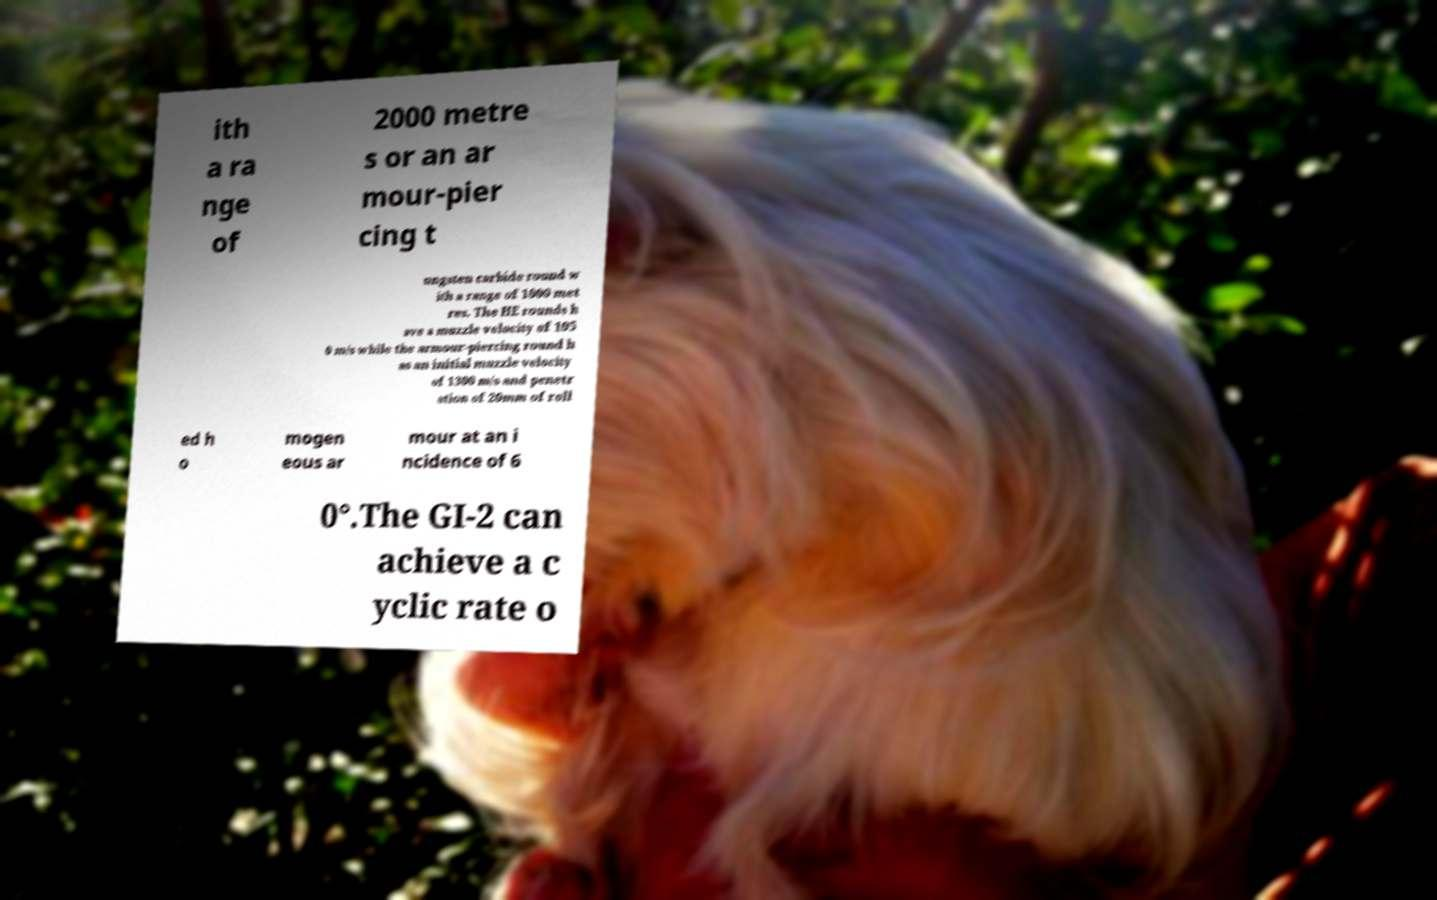I need the written content from this picture converted into text. Can you do that? ith a ra nge of 2000 metre s or an ar mour-pier cing t ungsten carbide round w ith a range of 1000 met res. The HE rounds h ave a muzzle velocity of 105 0 m/s while the armour-piercing round h as an initial muzzle velocity of 1300 m/s and penetr ation of 20mm of roll ed h o mogen eous ar mour at an i ncidence of 6 0°.The GI-2 can achieve a c yclic rate o 